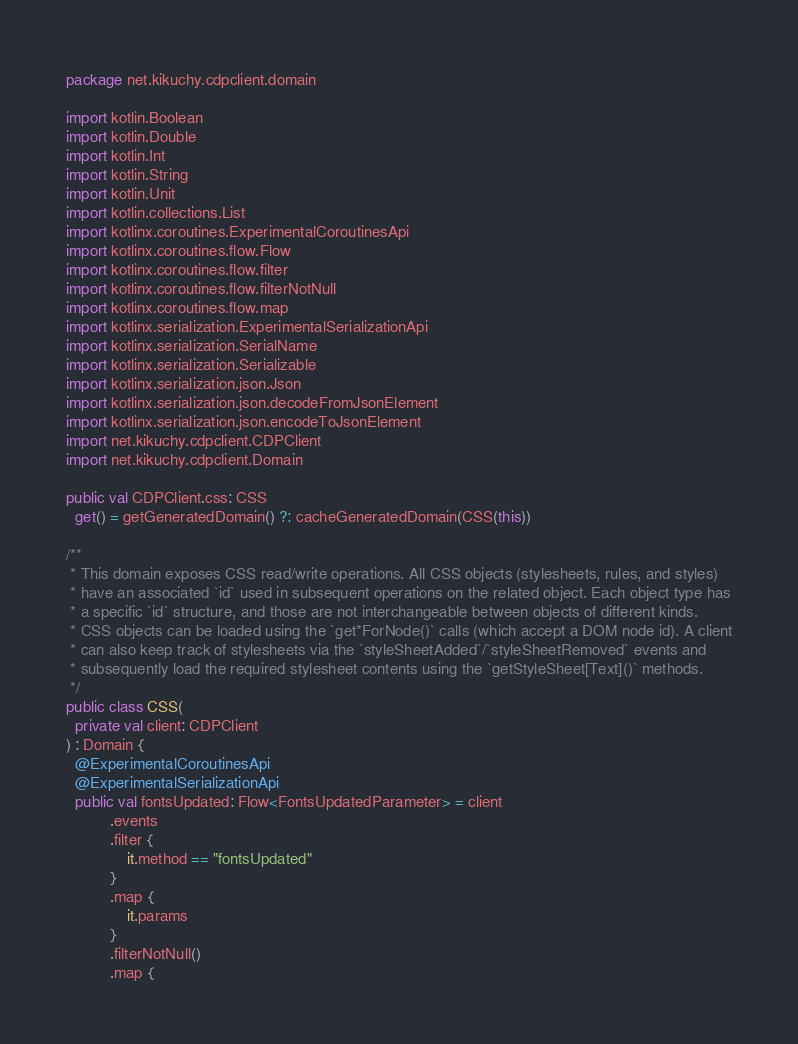<code> <loc_0><loc_0><loc_500><loc_500><_Kotlin_>package net.kikuchy.cdpclient.domain

import kotlin.Boolean
import kotlin.Double
import kotlin.Int
import kotlin.String
import kotlin.Unit
import kotlin.collections.List
import kotlinx.coroutines.ExperimentalCoroutinesApi
import kotlinx.coroutines.flow.Flow
import kotlinx.coroutines.flow.filter
import kotlinx.coroutines.flow.filterNotNull
import kotlinx.coroutines.flow.map
import kotlinx.serialization.ExperimentalSerializationApi
import kotlinx.serialization.SerialName
import kotlinx.serialization.Serializable
import kotlinx.serialization.json.Json
import kotlinx.serialization.json.decodeFromJsonElement
import kotlinx.serialization.json.encodeToJsonElement
import net.kikuchy.cdpclient.CDPClient
import net.kikuchy.cdpclient.Domain

public val CDPClient.css: CSS
  get() = getGeneratedDomain() ?: cacheGeneratedDomain(CSS(this))

/**
 * This domain exposes CSS read/write operations. All CSS objects (stylesheets, rules, and styles)
 * have an associated `id` used in subsequent operations on the related object. Each object type has
 * a specific `id` structure, and those are not interchangeable between objects of different kinds.
 * CSS objects can be loaded using the `get*ForNode()` calls (which accept a DOM node id). A client
 * can also keep track of stylesheets via the `styleSheetAdded`/`styleSheetRemoved` events and
 * subsequently load the required stylesheet contents using the `getStyleSheet[Text]()` methods.
 */
public class CSS(
  private val client: CDPClient
) : Domain {
  @ExperimentalCoroutinesApi
  @ExperimentalSerializationApi
  public val fontsUpdated: Flow<FontsUpdatedParameter> = client
          .events
          .filter {
              it.method == "fontsUpdated"
          }
          .map {
              it.params
          }
          .filterNotNull()
          .map {</code> 